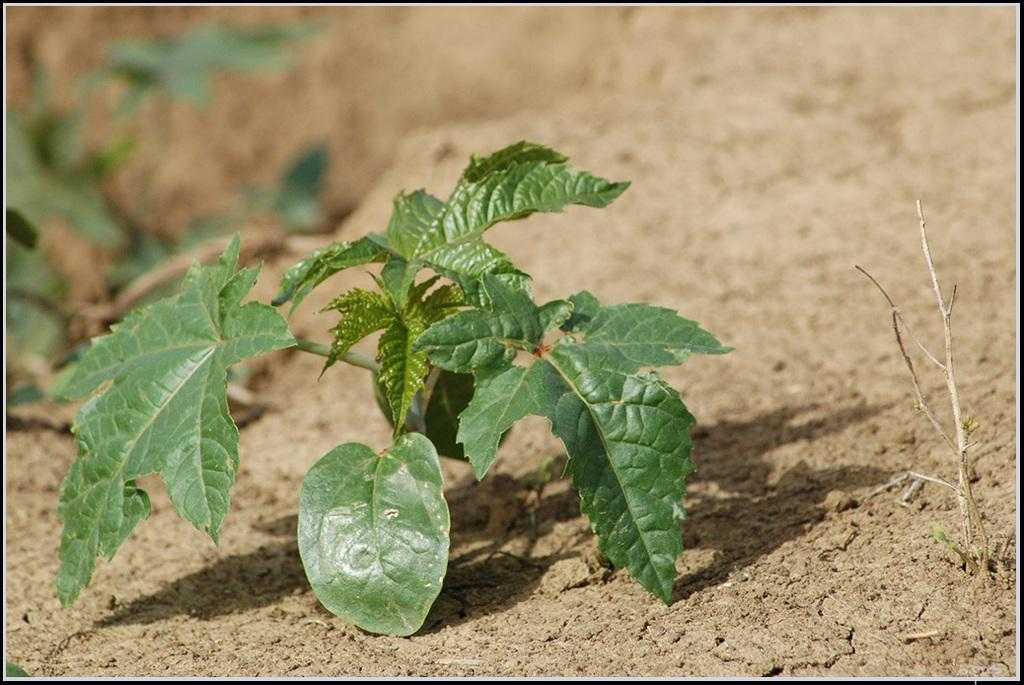How many plants are visible in the image? There are two plants in the image. Where are the plants located in the image? The plants are on the ground. What type of game is being played by the plants in the image? There is no game being played by the plants in the image, as plants do not have the ability to play games. 